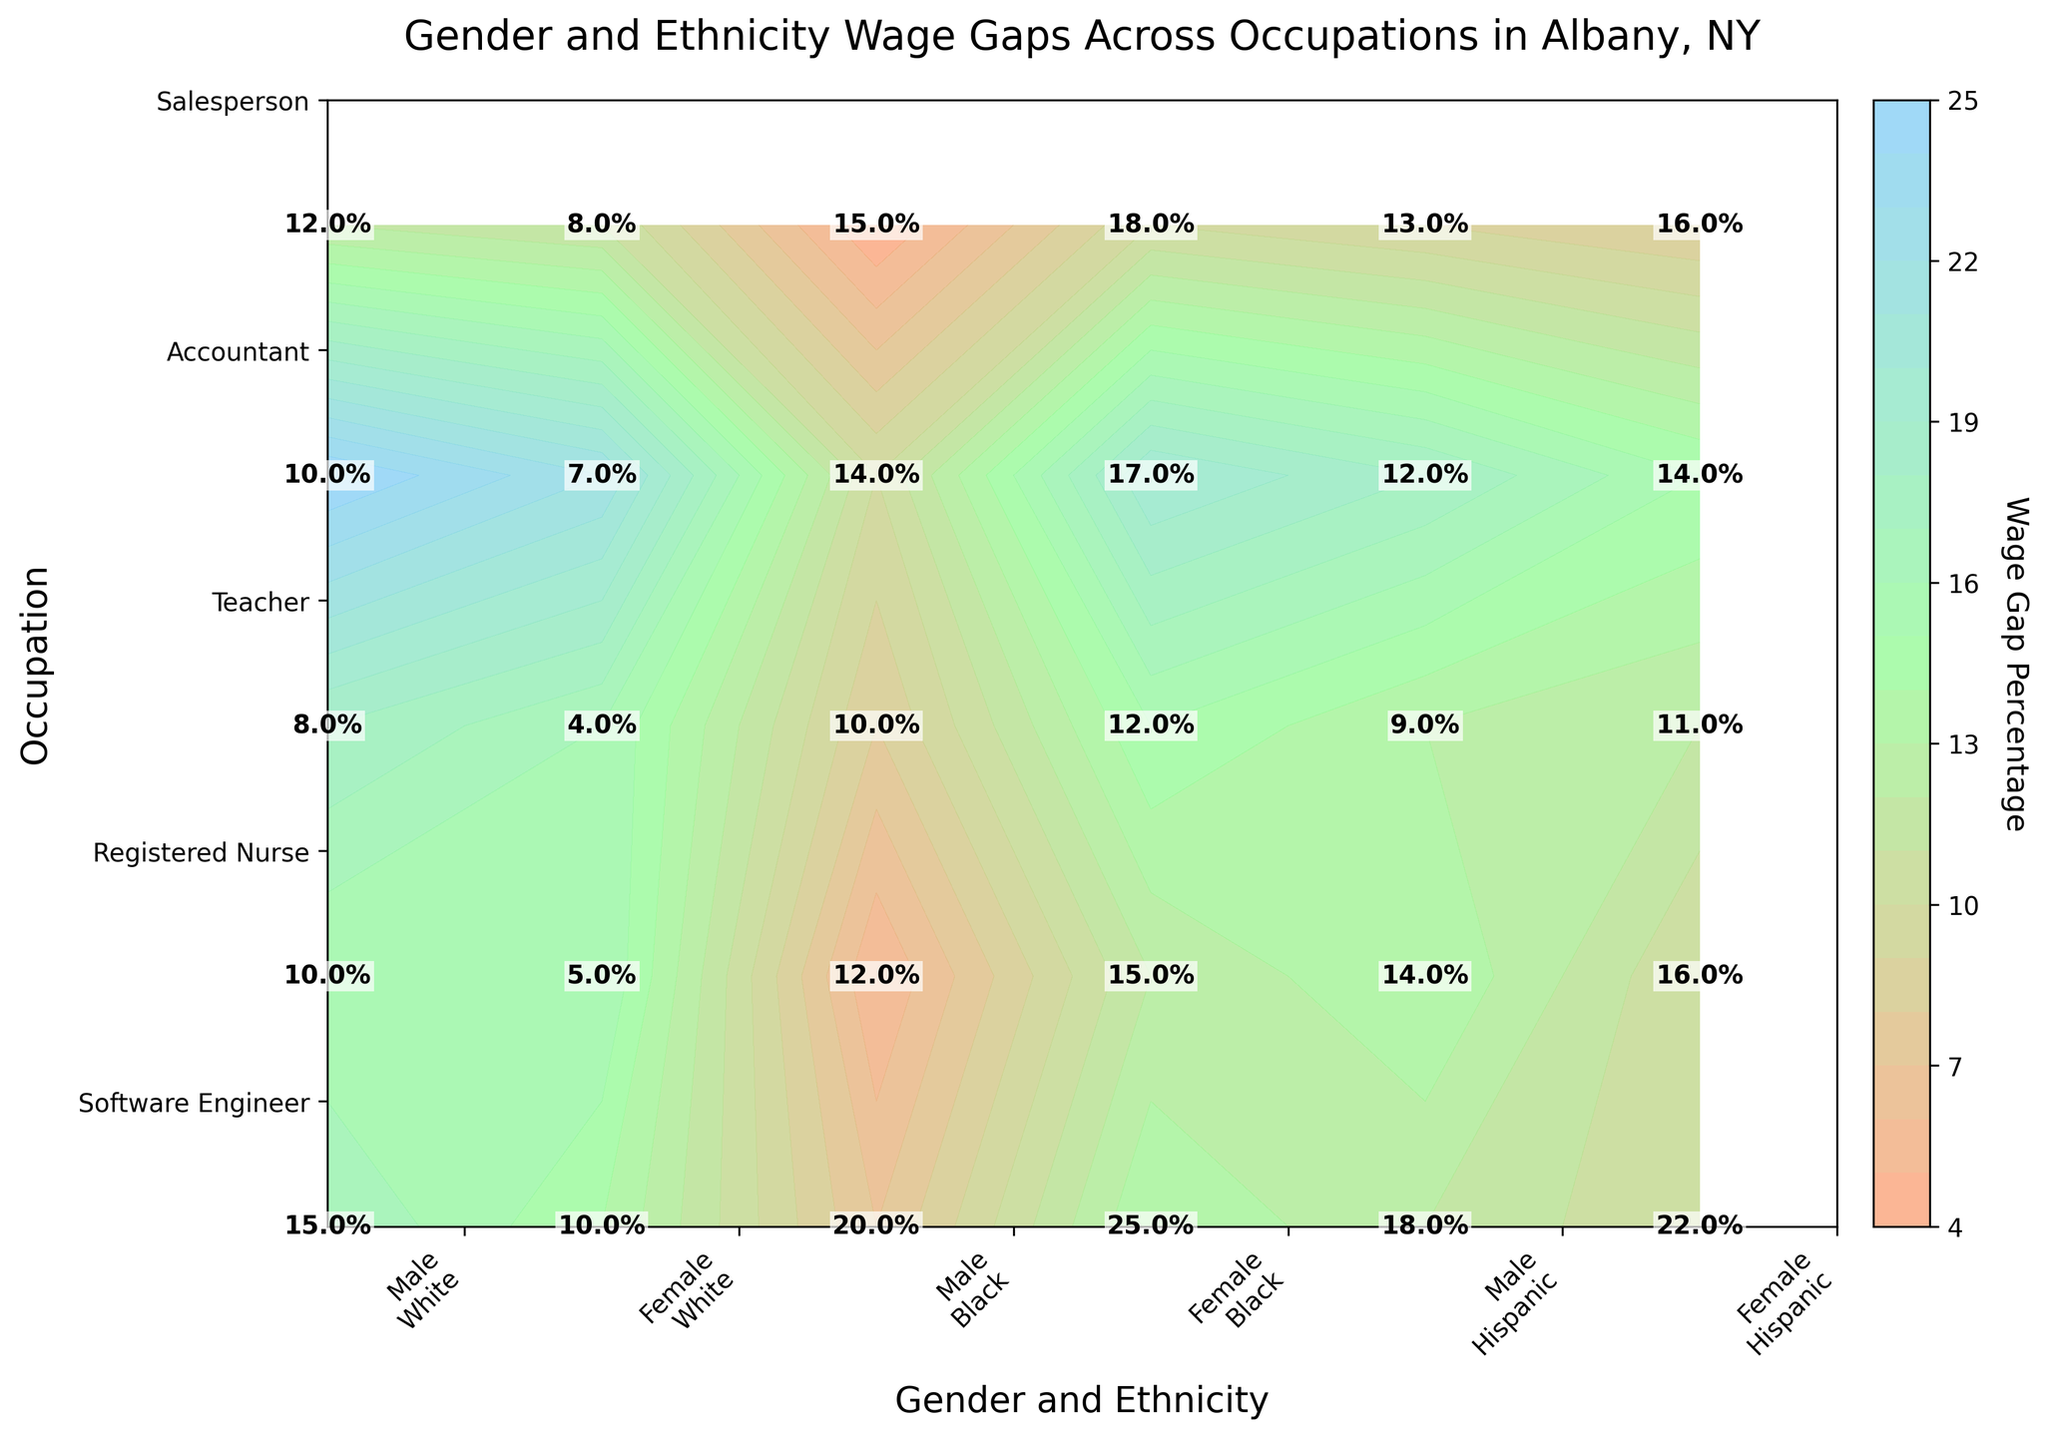what is the title of the figure? The title of a figure is typically located at the top of the plot. In this case, it reads "Gender and Ethnicity Wage Gaps Across Occupations in Albany, NY." The title is easy to identify as it is usually prominent and formatted in a larger or bolder font than other text elements.
Answer: Gender and Ethnicity Wage Gaps Across Occupations in Albany, NY How many occupations are compared in this plot? The number of occupations can be determined by counting the unique labels on the y-axis. Here we see labels for Software Engineer, Registered Nurse, Teacher, Accountant, and Salesperson.
Answer: 5 Which occupation has the highest wage gap for Black females? To find this, look for the highest value in the row corresponding to Black females across all occupations. The row with the label "Black" and "Female" in the column headers shows 25 for Software Engineer, which is the highest among Black females.
Answer: Software Engineer What is the difference in wage gap percentages between Black male and Black female Software Engineers? Locate the wage gap values for Black male and female Software Engineers. These are 20% and 25% respectively. Subtract the lower value from the higher value: 25 - 20 = 5 percentage points.
Answer: 5% Which gender and ethnicity group has the smallest wage gap among Teachers? Find the row corresponding to Teachers and then locate the smallest value across all gender and ethnicity groups. Teachers have the smallest wage gap for White females at 4%.
Answer: White females What is the average wage gap percentage for Hispanic females across all occupations? Calculate the average by summing the wage gaps for Hispanic females in each occupation and dividing by the number of occupations. The values are 22, 16, 11, 14, and 16. Add these up (22 + 16 + 11 + 14 + 16 = 79) and divide by 5 (79 / 5 = 15.8).
Answer: 15.8% Which gender has a generally higher wage gap across all occupations? Compare the contour shade and labels between males and females for each ethnicity and occupation. Generally, darker shades and higher values indicate higher gaps. Males tend to have higher wage gap percentages in most cases.
Answer: Males Is the wage gap higher for Hispanic males or White females in Salesperson occupation? Locate the values for Hispanic males and White females in the Salesperson row. Hispanic males have a wage gap of 13%, while White females have 8%. Thus, the wage gap is higher for Hispanic males.
Answer: Hispanic males Which occupation has the smallest difference in wage gap percentages between genders for the same ethnicity? Compare the values for males and females within the same ethnicity across all occupations and identify the smallest difference. For Registered Nurse, the differences are minimal: White (5%), Black (3%), and Hispanic (2%). The smallest difference is 2% for Hispanic Registered Nurse.
Answer: Registered Nurse 